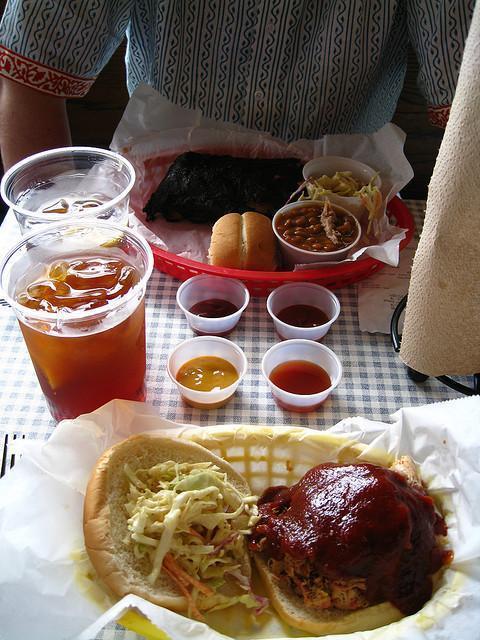What type of sandwich is being served?
Answer the question by selecting the correct answer among the 4 following choices.
Options: Club, peanut butter, barbeque, tuna. Barbeque. 